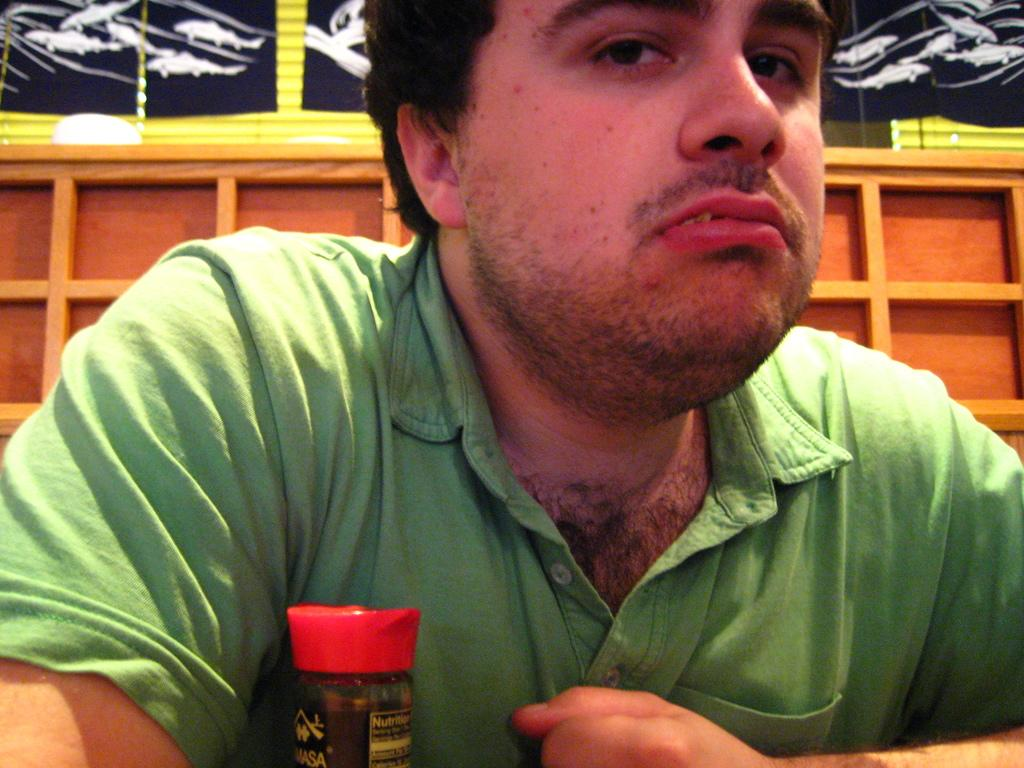What can be seen in the image? There is a person in the image. What is the person wearing? The person is wearing a green t-shirt. What is in front of the person? There is an object in front of the person. What type of surface can be seen in the background of the image? There is a wooden surface in the background of the image. What else can be seen in the background of the image? There are other objects visible in the background of the image. What type of weather can be seen on the island in the image? There is no island present in the image, and therefore no weather can be observed. 